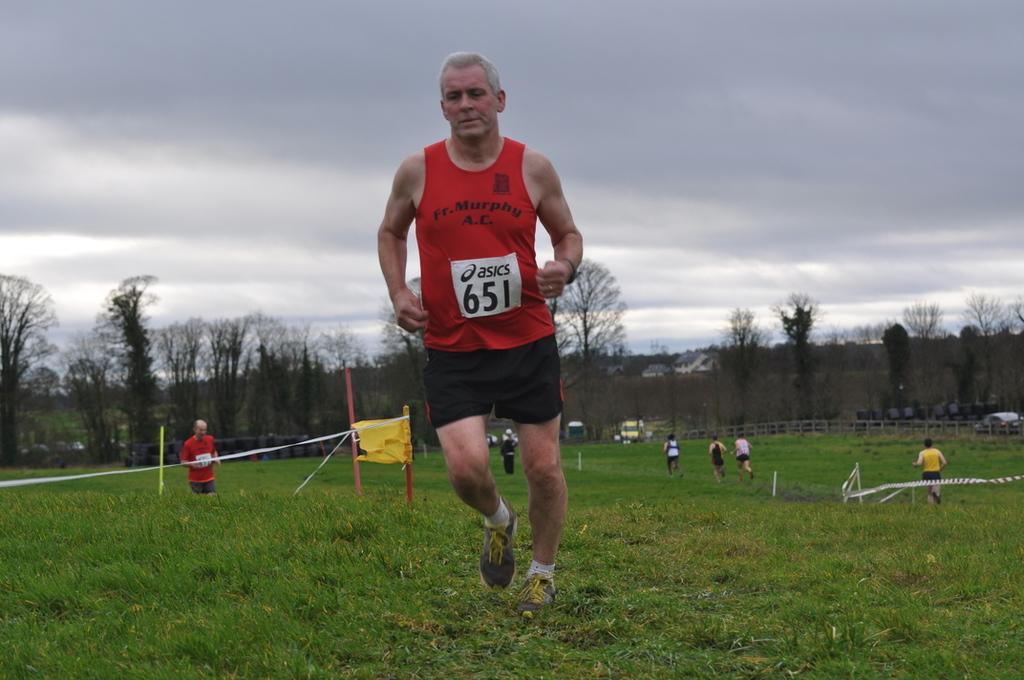Describe this image in one or two sentences. In the foreground of this image, there is a man running on the grass. In the background, there are safety poles, persons running, trees, houses and the cloud. 